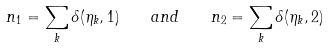Convert formula to latex. <formula><loc_0><loc_0><loc_500><loc_500>n _ { 1 } = \sum _ { k } \delta ( \eta _ { k } , 1 ) \quad a n d \quad n _ { 2 } = \sum _ { k } \delta ( \eta _ { k } , 2 )</formula> 